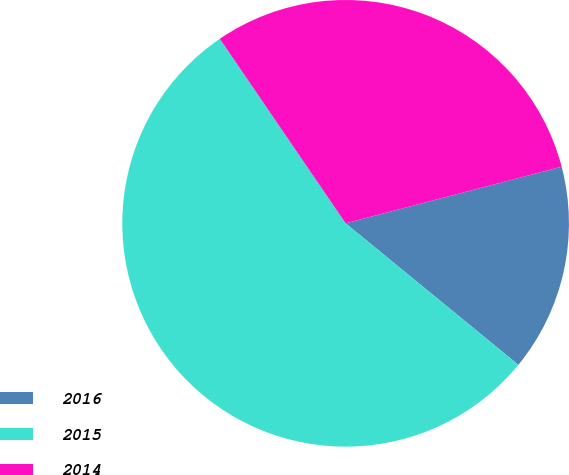<chart> <loc_0><loc_0><loc_500><loc_500><pie_chart><fcel>2016<fcel>2015<fcel>2014<nl><fcel>15.0%<fcel>54.55%<fcel>30.45%<nl></chart> 